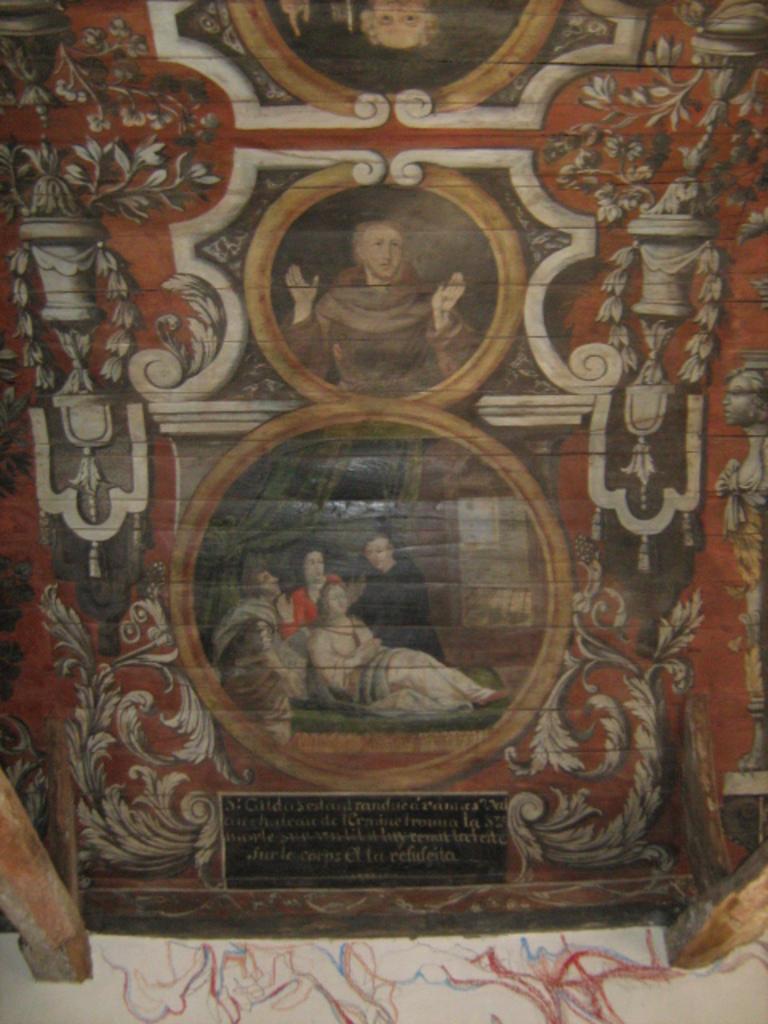Describe this image in one or two sentences. In this image I can see a painting is on the board. We can see images and something is written on the board.   